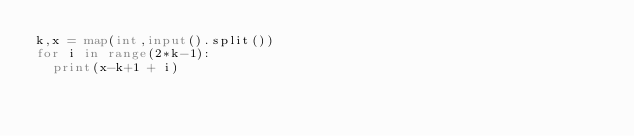<code> <loc_0><loc_0><loc_500><loc_500><_Python_>k,x = map(int,input().split())
for i in range(2*k-1):
  print(x-k+1 + i)</code> 